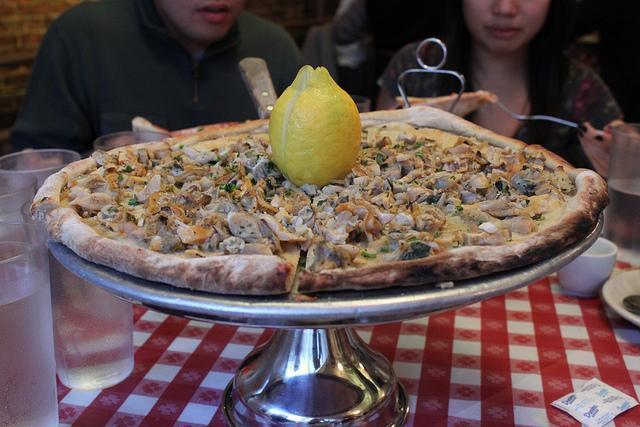How many slices of pizza are there?
Give a very brief answer. 8. How many cups are there?
Give a very brief answer. 4. How many people are there?
Give a very brief answer. 2. How many people have a umbrella in the picture?
Give a very brief answer. 0. 